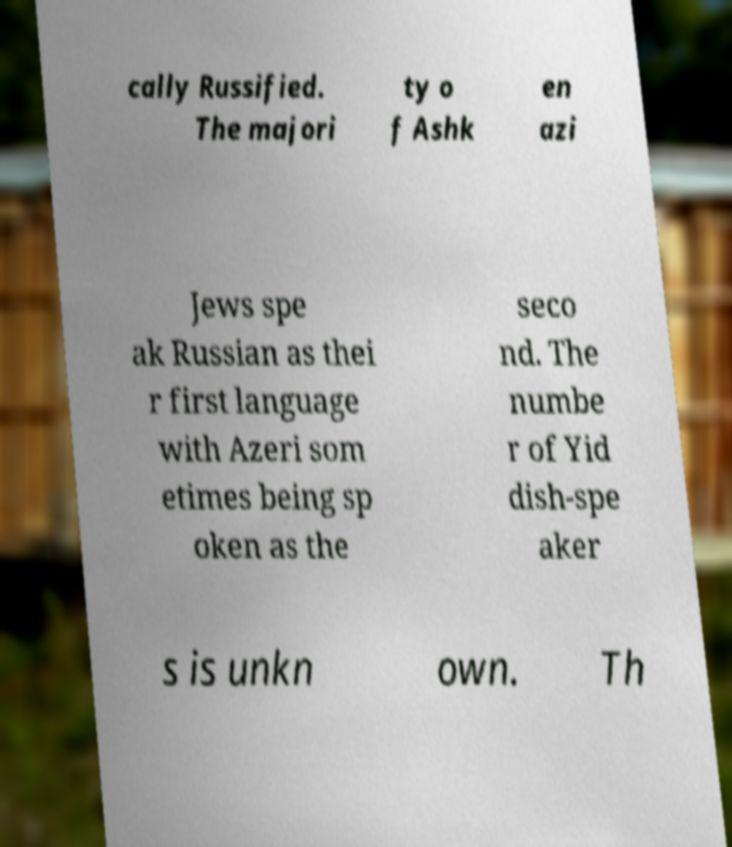Can you read and provide the text displayed in the image?This photo seems to have some interesting text. Can you extract and type it out for me? cally Russified. The majori ty o f Ashk en azi Jews spe ak Russian as thei r first language with Azeri som etimes being sp oken as the seco nd. The numbe r of Yid dish-spe aker s is unkn own. Th 